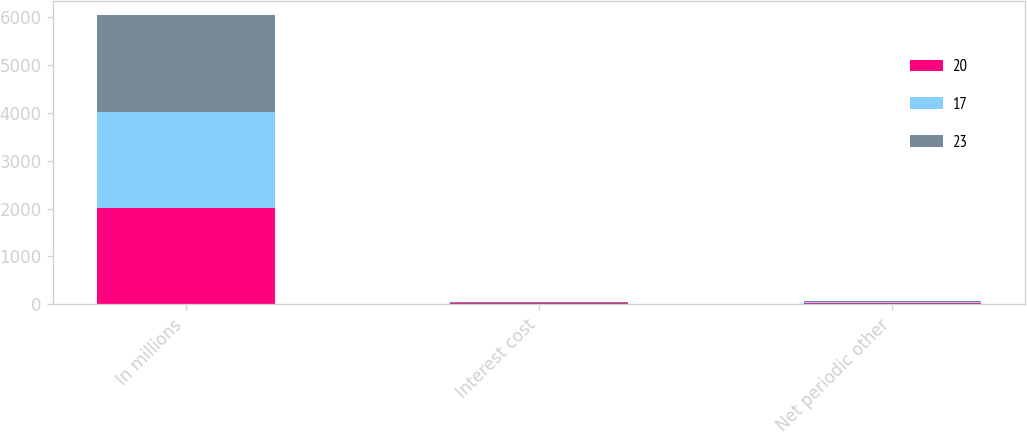Convert chart. <chart><loc_0><loc_0><loc_500><loc_500><stacked_bar_chart><ecel><fcel>In millions<fcel>Interest cost<fcel>Net periodic other<nl><fcel>20<fcel>2014<fcel>17<fcel>17<nl><fcel>17<fcel>2013<fcel>17<fcel>23<nl><fcel>23<fcel>2012<fcel>21<fcel>20<nl></chart> 